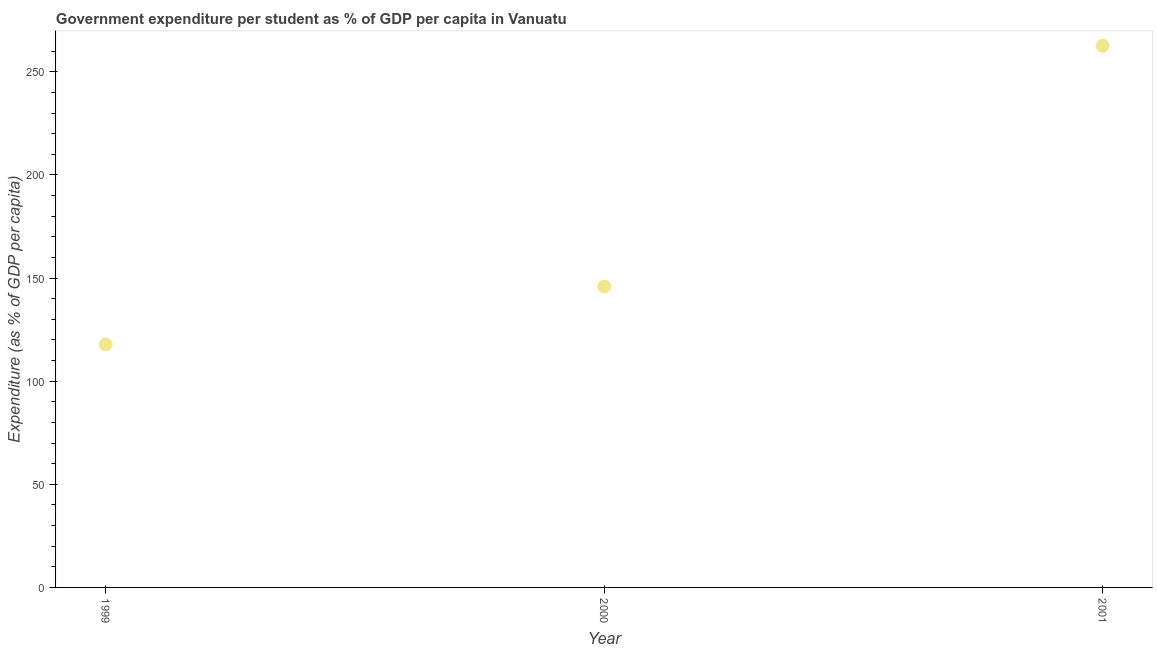What is the government expenditure per student in 1999?
Your answer should be compact. 117.86. Across all years, what is the maximum government expenditure per student?
Your answer should be compact. 262.67. Across all years, what is the minimum government expenditure per student?
Your answer should be very brief. 117.86. In which year was the government expenditure per student minimum?
Provide a succinct answer. 1999. What is the sum of the government expenditure per student?
Make the answer very short. 526.45. What is the difference between the government expenditure per student in 1999 and 2000?
Your response must be concise. -28.06. What is the average government expenditure per student per year?
Offer a terse response. 175.48. What is the median government expenditure per student?
Provide a short and direct response. 145.92. In how many years, is the government expenditure per student greater than 130 %?
Offer a terse response. 2. What is the ratio of the government expenditure per student in 1999 to that in 2001?
Your answer should be very brief. 0.45. Is the government expenditure per student in 2000 less than that in 2001?
Your answer should be very brief. Yes. Is the difference between the government expenditure per student in 1999 and 2001 greater than the difference between any two years?
Offer a very short reply. Yes. What is the difference between the highest and the second highest government expenditure per student?
Keep it short and to the point. 116.75. Is the sum of the government expenditure per student in 2000 and 2001 greater than the maximum government expenditure per student across all years?
Your response must be concise. Yes. What is the difference between the highest and the lowest government expenditure per student?
Your answer should be very brief. 144.81. In how many years, is the government expenditure per student greater than the average government expenditure per student taken over all years?
Offer a very short reply. 1. Does the graph contain any zero values?
Provide a short and direct response. No. What is the title of the graph?
Your answer should be very brief. Government expenditure per student as % of GDP per capita in Vanuatu. What is the label or title of the Y-axis?
Your answer should be very brief. Expenditure (as % of GDP per capita). What is the Expenditure (as % of GDP per capita) in 1999?
Provide a short and direct response. 117.86. What is the Expenditure (as % of GDP per capita) in 2000?
Provide a short and direct response. 145.92. What is the Expenditure (as % of GDP per capita) in 2001?
Offer a very short reply. 262.67. What is the difference between the Expenditure (as % of GDP per capita) in 1999 and 2000?
Provide a short and direct response. -28.06. What is the difference between the Expenditure (as % of GDP per capita) in 1999 and 2001?
Make the answer very short. -144.81. What is the difference between the Expenditure (as % of GDP per capita) in 2000 and 2001?
Offer a terse response. -116.75. What is the ratio of the Expenditure (as % of GDP per capita) in 1999 to that in 2000?
Offer a terse response. 0.81. What is the ratio of the Expenditure (as % of GDP per capita) in 1999 to that in 2001?
Your response must be concise. 0.45. What is the ratio of the Expenditure (as % of GDP per capita) in 2000 to that in 2001?
Give a very brief answer. 0.56. 